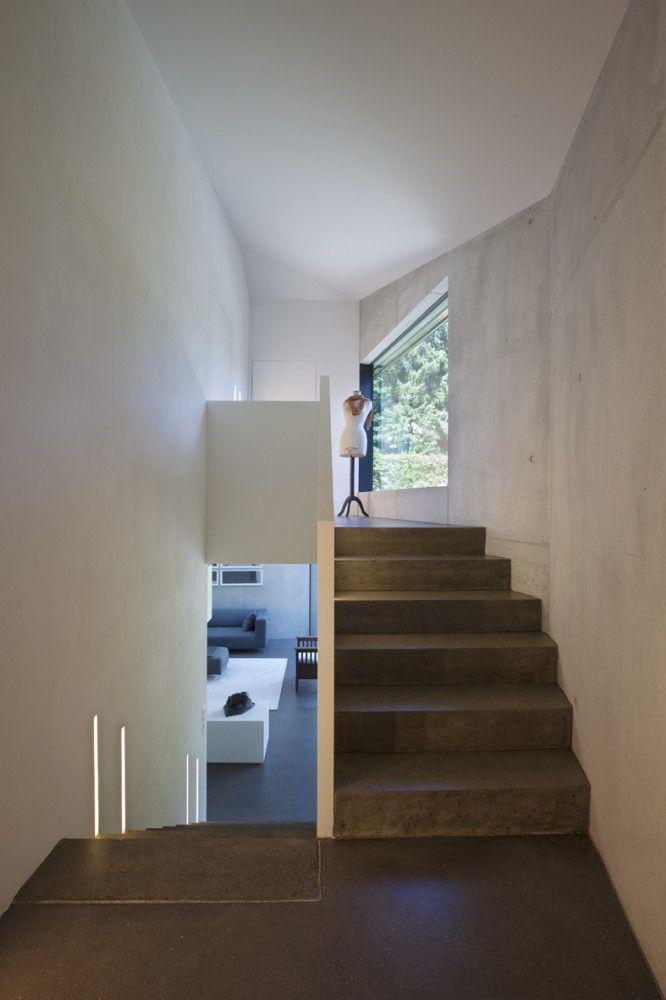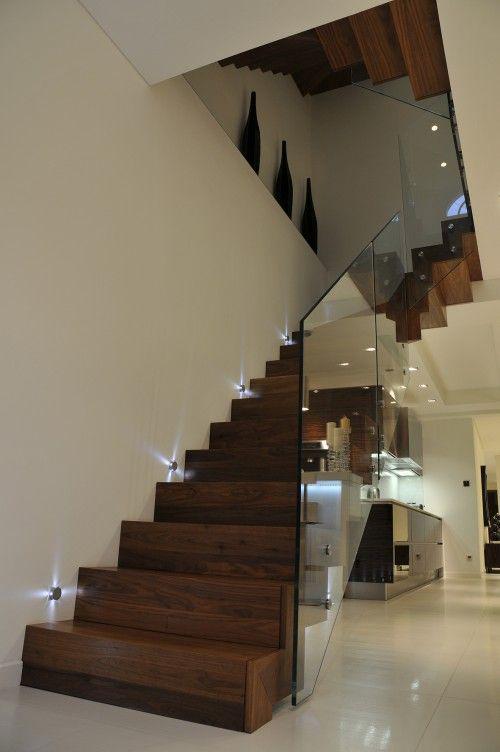The first image is the image on the left, the second image is the image on the right. Given the left and right images, does the statement "The stairway in the image on the right is bordered with glass panels." hold true? Answer yes or no. Yes. The first image is the image on the left, the second image is the image on the right. For the images shown, is this caption "An image shows an upward view of an uncurved ascending staircase with glass panels on one side." true? Answer yes or no. Yes. 